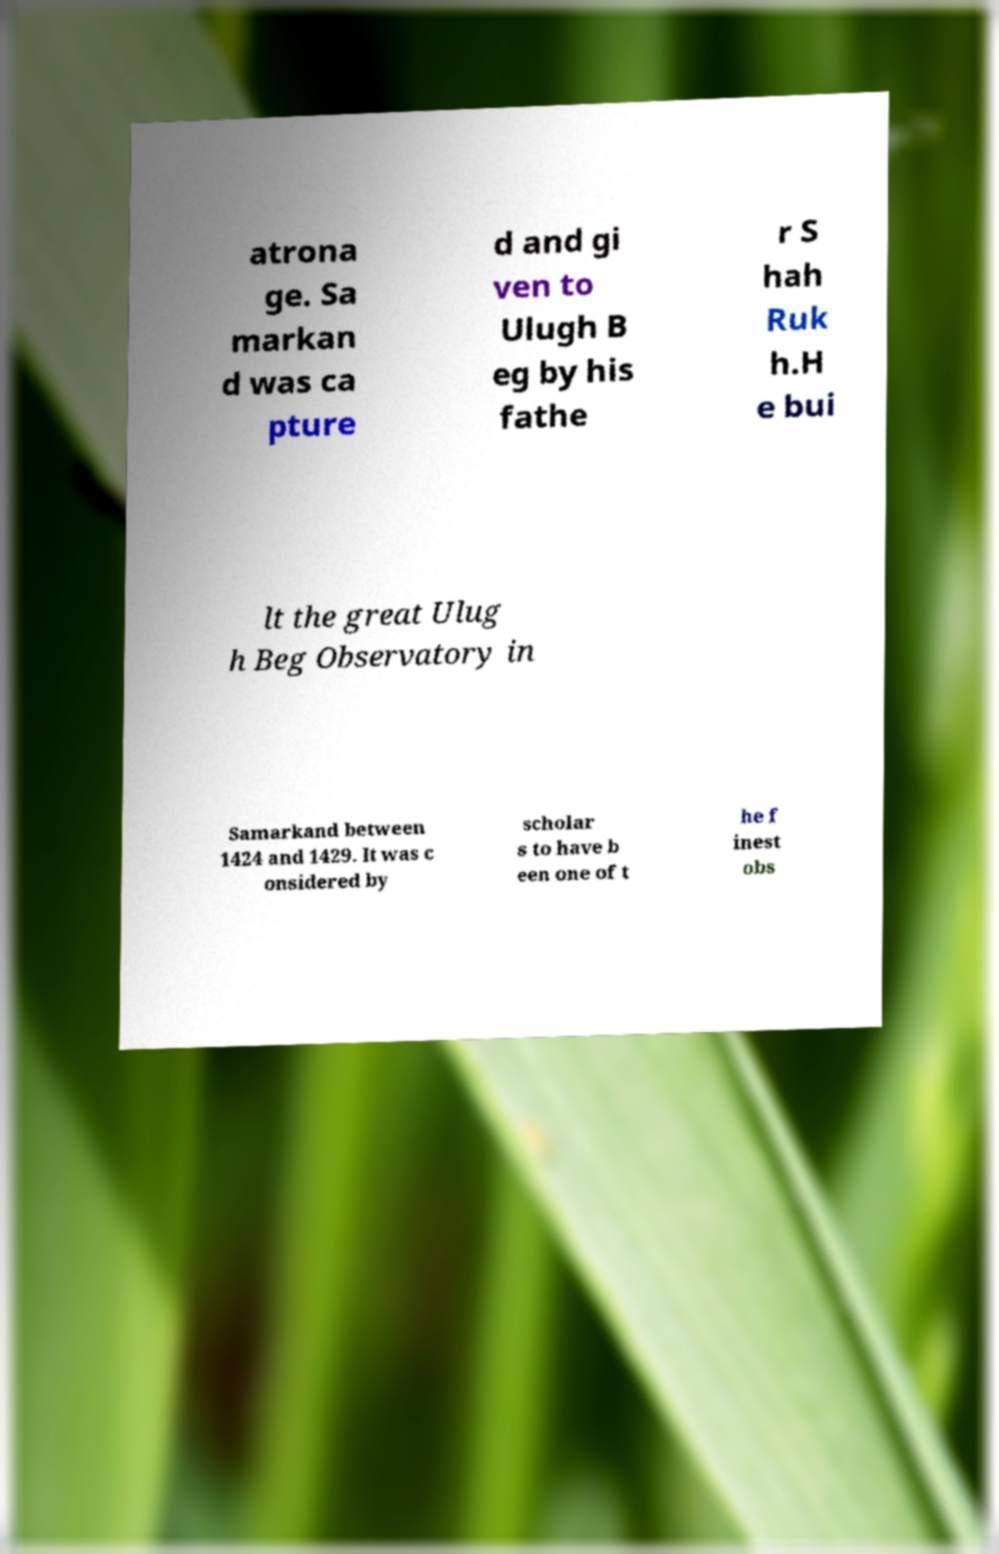Could you extract and type out the text from this image? atrona ge. Sa markan d was ca pture d and gi ven to Ulugh B eg by his fathe r S hah Ruk h.H e bui lt the great Ulug h Beg Observatory in Samarkand between 1424 and 1429. It was c onsidered by scholar s to have b een one of t he f inest obs 